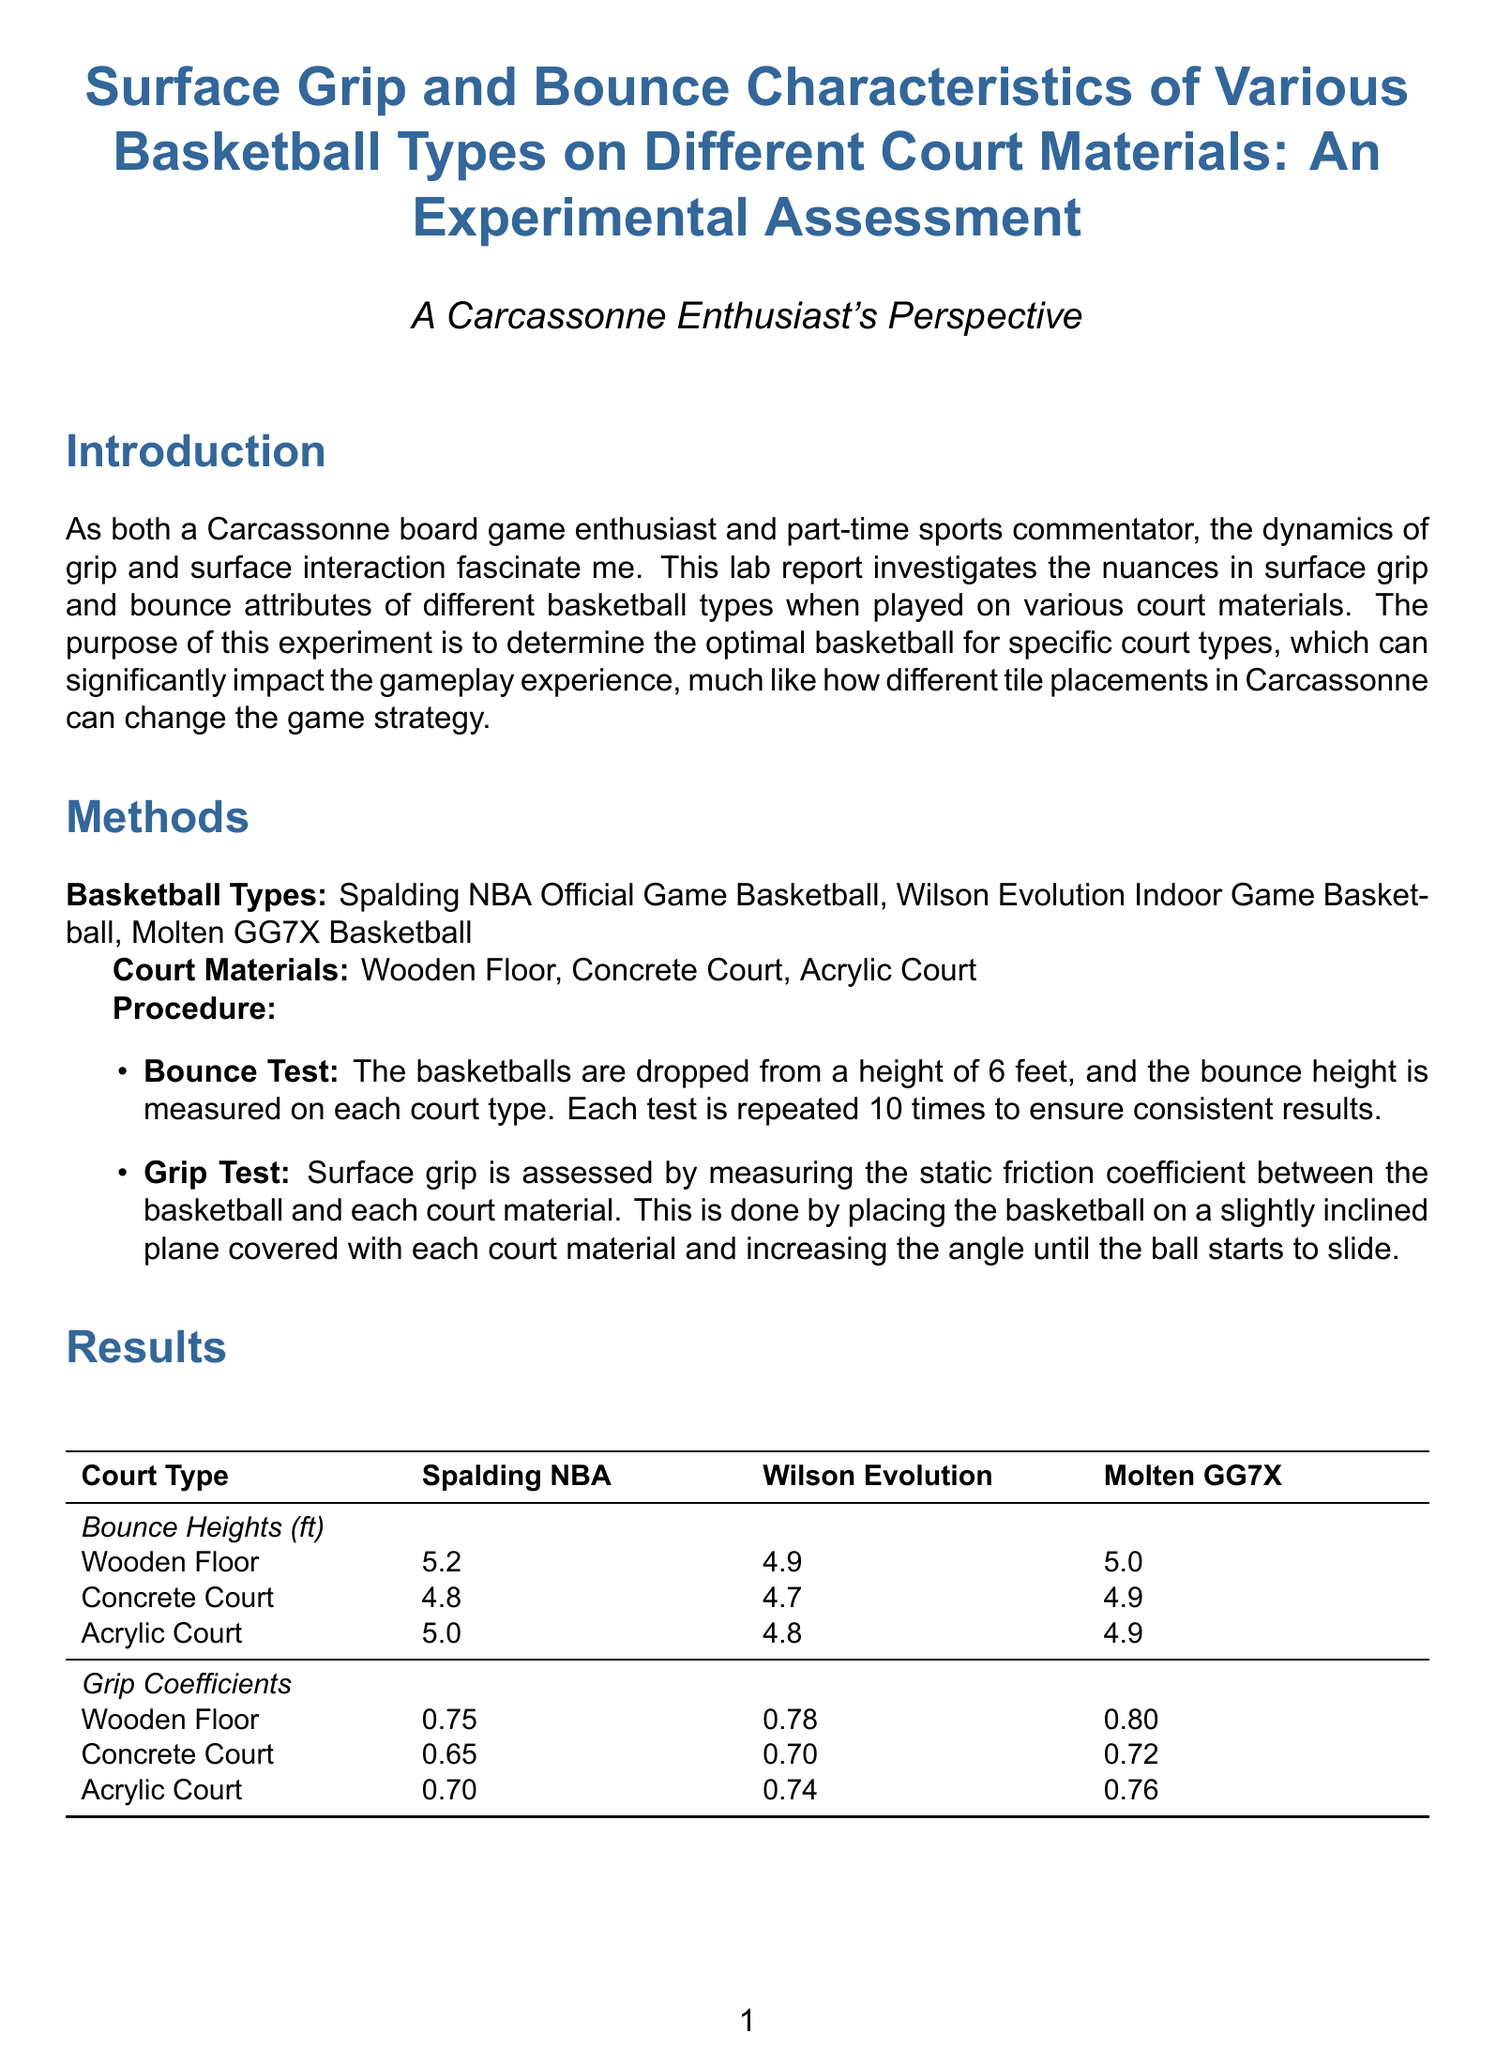What are the types of basketballs tested? The document lists the basketball types used in the experiment, which are the Spalding NBA Official Game Basketball, Wilson Evolution Indoor Game Basketball, and Molten GG7X Basketball.
Answer: Spalding NBA, Wilson Evolution, Molten GG7X What court material produced the highest grip coefficient for the Molten GG7X? The grip coefficients for the Molten GG7X are compared across different court materials, showing that the highest grip was on the Wooden Floor.
Answer: Wooden Floor What was the bounce height for the Spalding NBA basketball on the Concrete Court? The document provides direct bounce height measurements by basketball type and court material, indicating the height is 4.8 feet for the Spalding NBA basketball on Concrete Court.
Answer: 4.8 Which basketball type is recommended for indoor courts? The recommendations section specifies that for indoor courts, the Spalding NBA basketball is suggested due to its superior bounce performance.
Answer: Spalding NBA What is the static friction coefficient on the Acrylic Court for the Wilson Evolution basketball? The grip coefficients section indicates that the Wilson Evolution basketball has a static friction coefficient of 0.74 on the Acrylic Court.
Answer: 0.74 How many times were the tests repeated to ensure consistency? The procedure mentions that each test is repeated 10 times to ensure consistent results, providing the assurance of accuracy in the data.
Answer: 10 Which basketball type had the best grip across all surfaces? The discussion states that the Molten GG7X presented the best grip overall, indicating its performance in all tested conditions.
Answer: Molten GG7X What height were the basketballs dropped from during the bounce test? The procedure outlines that the basketballs were dropped from a height of 6 feet for the bounce test.
Answer: 6 feet 